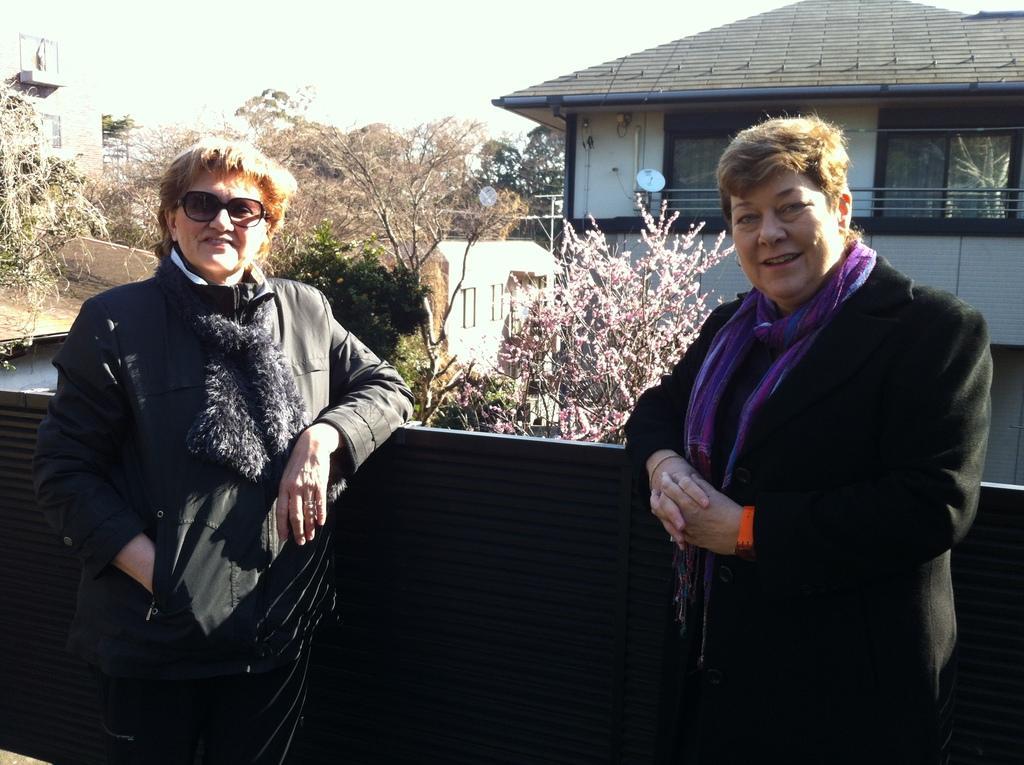How would you summarize this image in a sentence or two? Here I can see two persons standing, leaning to a gate, smiling and giving pose for the picture. In the background there are buildings and trees. At the top of the image I can see the sky. 